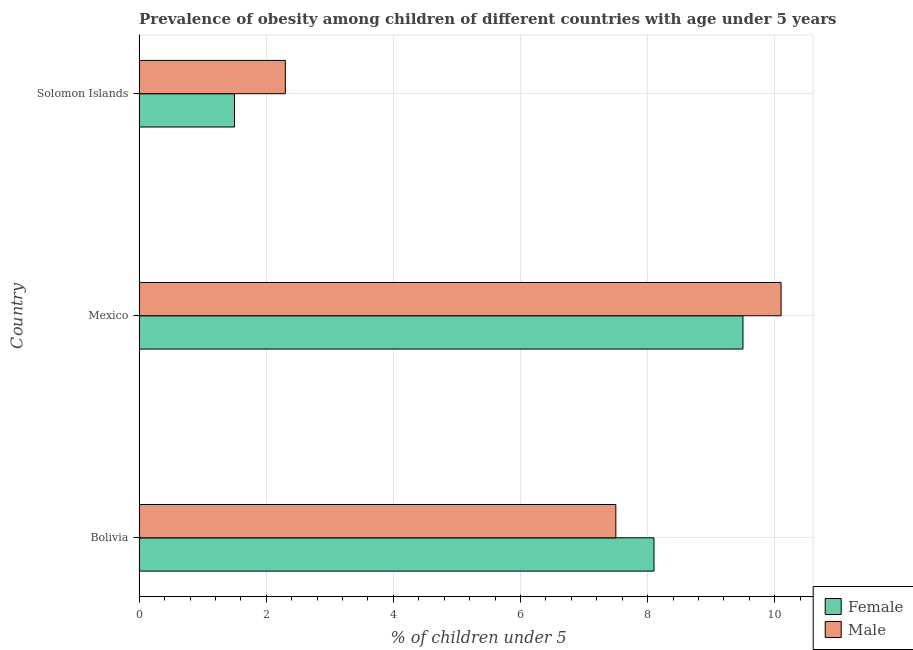How many different coloured bars are there?
Give a very brief answer. 2. Are the number of bars per tick equal to the number of legend labels?
Offer a very short reply. Yes. Are the number of bars on each tick of the Y-axis equal?
Offer a very short reply. Yes. How many bars are there on the 2nd tick from the bottom?
Give a very brief answer. 2. What is the label of the 3rd group of bars from the top?
Provide a short and direct response. Bolivia. In how many cases, is the number of bars for a given country not equal to the number of legend labels?
Offer a very short reply. 0. What is the percentage of obese male children in Solomon Islands?
Make the answer very short. 2.3. Across all countries, what is the maximum percentage of obese female children?
Provide a short and direct response. 9.5. Across all countries, what is the minimum percentage of obese female children?
Your answer should be compact. 1.5. In which country was the percentage of obese female children maximum?
Offer a very short reply. Mexico. In which country was the percentage of obese male children minimum?
Offer a terse response. Solomon Islands. What is the total percentage of obese female children in the graph?
Your response must be concise. 19.1. What is the difference between the percentage of obese female children in Mexico and that in Solomon Islands?
Provide a short and direct response. 8. What is the average percentage of obese male children per country?
Keep it short and to the point. 6.63. In how many countries, is the percentage of obese male children greater than 6 %?
Your response must be concise. 2. What is the ratio of the percentage of obese female children in Bolivia to that in Mexico?
Give a very brief answer. 0.85. Is the percentage of obese male children in Bolivia less than that in Solomon Islands?
Provide a succinct answer. No. What is the difference between the highest and the second highest percentage of obese female children?
Keep it short and to the point. 1.4. In how many countries, is the percentage of obese female children greater than the average percentage of obese female children taken over all countries?
Give a very brief answer. 2. What does the 1st bar from the bottom in Bolivia represents?
Keep it short and to the point. Female. What is the difference between two consecutive major ticks on the X-axis?
Your answer should be very brief. 2. Where does the legend appear in the graph?
Provide a succinct answer. Bottom right. How many legend labels are there?
Your answer should be very brief. 2. What is the title of the graph?
Your response must be concise. Prevalence of obesity among children of different countries with age under 5 years. Does "Private consumption" appear as one of the legend labels in the graph?
Provide a succinct answer. No. What is the label or title of the X-axis?
Keep it short and to the point.  % of children under 5. What is the  % of children under 5 of Female in Bolivia?
Provide a short and direct response. 8.1. What is the  % of children under 5 of Female in Mexico?
Make the answer very short. 9.5. What is the  % of children under 5 of Male in Mexico?
Provide a short and direct response. 10.1. What is the  % of children under 5 in Female in Solomon Islands?
Give a very brief answer. 1.5. What is the  % of children under 5 in Male in Solomon Islands?
Offer a terse response. 2.3. Across all countries, what is the maximum  % of children under 5 in Female?
Your answer should be compact. 9.5. Across all countries, what is the maximum  % of children under 5 in Male?
Your answer should be very brief. 10.1. Across all countries, what is the minimum  % of children under 5 of Female?
Provide a succinct answer. 1.5. Across all countries, what is the minimum  % of children under 5 of Male?
Offer a very short reply. 2.3. What is the total  % of children under 5 in Female in the graph?
Offer a very short reply. 19.1. What is the difference between the  % of children under 5 in Male in Bolivia and that in Mexico?
Your response must be concise. -2.6. What is the difference between the  % of children under 5 in Female in Bolivia and that in Solomon Islands?
Your answer should be very brief. 6.6. What is the difference between the  % of children under 5 of Male in Mexico and that in Solomon Islands?
Offer a very short reply. 7.8. What is the difference between the  % of children under 5 in Female in Bolivia and the  % of children under 5 in Male in Mexico?
Your answer should be very brief. -2. What is the average  % of children under 5 of Female per country?
Ensure brevity in your answer.  6.37. What is the average  % of children under 5 of Male per country?
Your answer should be very brief. 6.63. What is the difference between the  % of children under 5 of Female and  % of children under 5 of Male in Bolivia?
Give a very brief answer. 0.6. What is the difference between the  % of children under 5 of Female and  % of children under 5 of Male in Solomon Islands?
Provide a succinct answer. -0.8. What is the ratio of the  % of children under 5 in Female in Bolivia to that in Mexico?
Keep it short and to the point. 0.85. What is the ratio of the  % of children under 5 in Male in Bolivia to that in Mexico?
Your response must be concise. 0.74. What is the ratio of the  % of children under 5 of Female in Bolivia to that in Solomon Islands?
Provide a succinct answer. 5.4. What is the ratio of the  % of children under 5 of Male in Bolivia to that in Solomon Islands?
Keep it short and to the point. 3.26. What is the ratio of the  % of children under 5 of Female in Mexico to that in Solomon Islands?
Your answer should be very brief. 6.33. What is the ratio of the  % of children under 5 of Male in Mexico to that in Solomon Islands?
Your answer should be very brief. 4.39. What is the difference between the highest and the second highest  % of children under 5 in Male?
Make the answer very short. 2.6. What is the difference between the highest and the lowest  % of children under 5 in Male?
Provide a succinct answer. 7.8. 